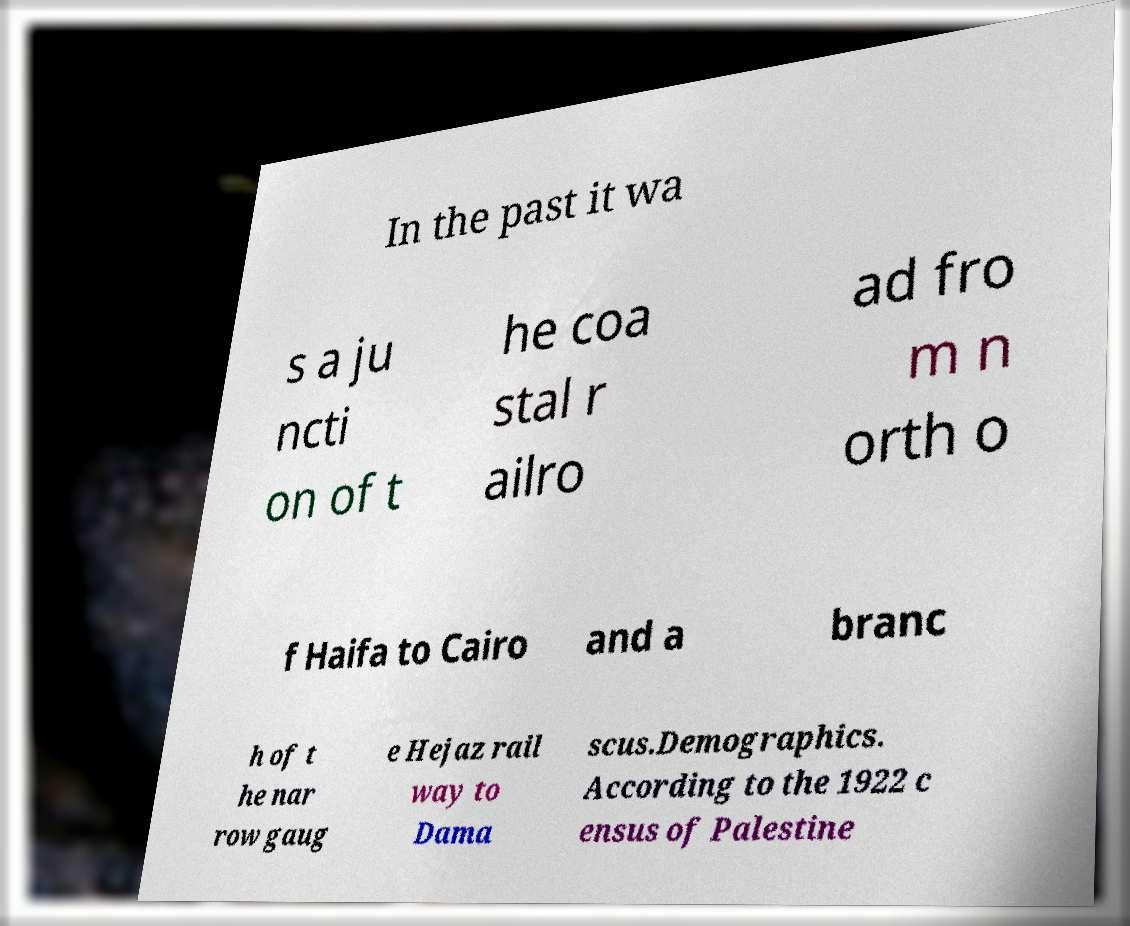What messages or text are displayed in this image? I need them in a readable, typed format. In the past it wa s a ju ncti on of t he coa stal r ailro ad fro m n orth o f Haifa to Cairo and a branc h of t he nar row gaug e Hejaz rail way to Dama scus.Demographics. According to the 1922 c ensus of Palestine 